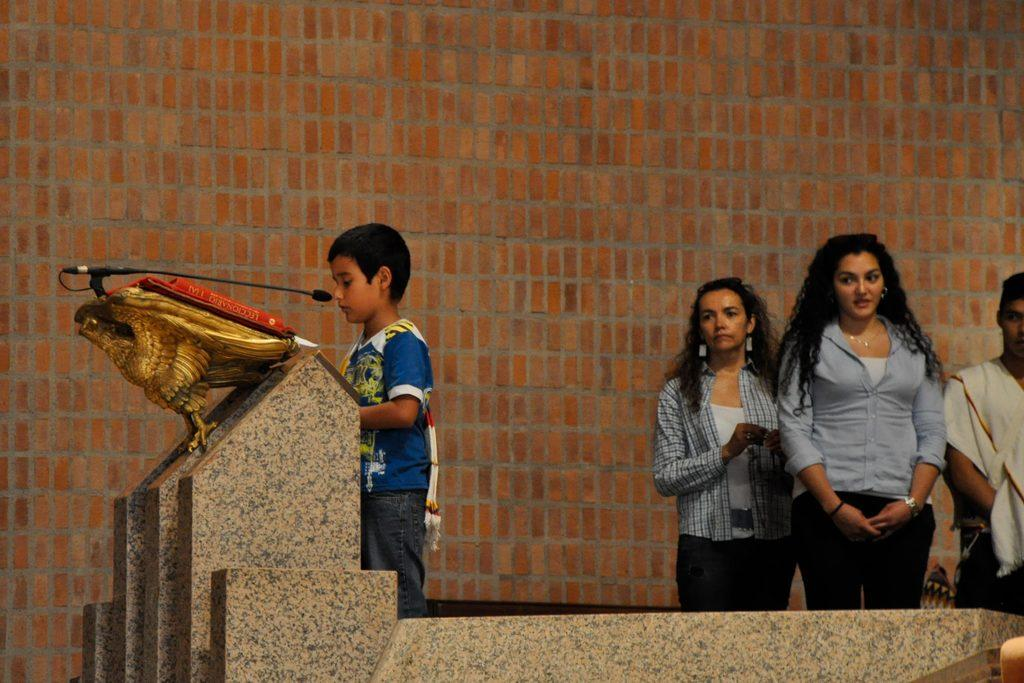How many people are in the image? There is a group of people in the image. What can be observed about the attire of the people in the image? The people are wearing different color dresses. What object is in front of one person in the image? There is a microphone in front of one person. What can be seen in the background of the image? There is a brown color brick wall in the background. Can you tell me how many rats are sitting on the brick wall in the image? There are no rats present in the image; it features a group of people and a brick wall. What type of cow can be seen interacting with the people in the image? There is no cow present in the image; it only features a group of people and a brick wall. 